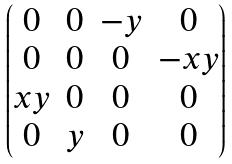Convert formula to latex. <formula><loc_0><loc_0><loc_500><loc_500>\begin{pmatrix} 0 & 0 & - y & 0 \\ 0 & 0 & 0 & - x y \\ x y & 0 & 0 & 0 \\ 0 & y & 0 & 0 \end{pmatrix}</formula> 